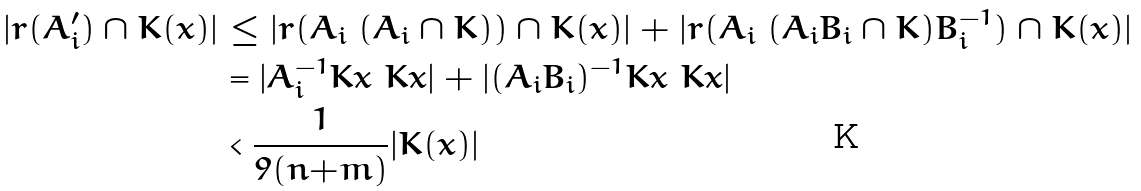<formula> <loc_0><loc_0><loc_500><loc_500>| r ( A ^ { \prime } _ { i } ) \cap K ( x ) | & \leq | r ( A _ { i } \ ( A _ { i } \cap K ) ) \cap K ( x ) | + | r ( A _ { i } \ ( A _ { i } B _ { i } \cap K ) B _ { i } ^ { - 1 } ) \cap K ( x ) | \\ & = | A _ { i } ^ { - 1 } K x \ K x | + | ( A _ { i } B _ { i } ) ^ { - 1 } K x \ K x | \\ & < \frac { 1 } { 9 ( n { + } m ) } | K ( x ) |</formula> 